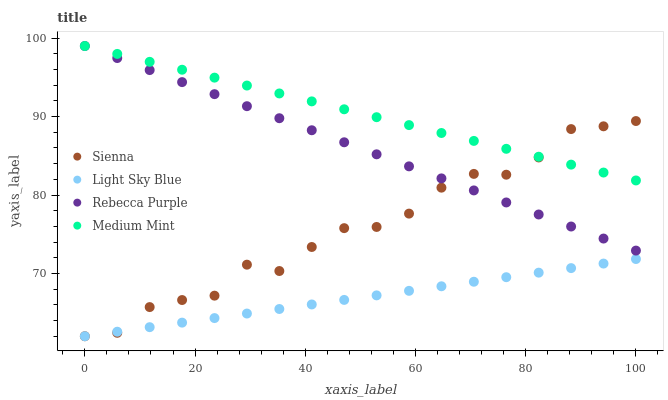Does Light Sky Blue have the minimum area under the curve?
Answer yes or no. Yes. Does Medium Mint have the maximum area under the curve?
Answer yes or no. Yes. Does Medium Mint have the minimum area under the curve?
Answer yes or no. No. Does Light Sky Blue have the maximum area under the curve?
Answer yes or no. No. Is Light Sky Blue the smoothest?
Answer yes or no. Yes. Is Sienna the roughest?
Answer yes or no. Yes. Is Medium Mint the smoothest?
Answer yes or no. No. Is Medium Mint the roughest?
Answer yes or no. No. Does Sienna have the lowest value?
Answer yes or no. Yes. Does Medium Mint have the lowest value?
Answer yes or no. No. Does Rebecca Purple have the highest value?
Answer yes or no. Yes. Does Light Sky Blue have the highest value?
Answer yes or no. No. Is Light Sky Blue less than Rebecca Purple?
Answer yes or no. Yes. Is Medium Mint greater than Light Sky Blue?
Answer yes or no. Yes. Does Medium Mint intersect Sienna?
Answer yes or no. Yes. Is Medium Mint less than Sienna?
Answer yes or no. No. Is Medium Mint greater than Sienna?
Answer yes or no. No. Does Light Sky Blue intersect Rebecca Purple?
Answer yes or no. No. 